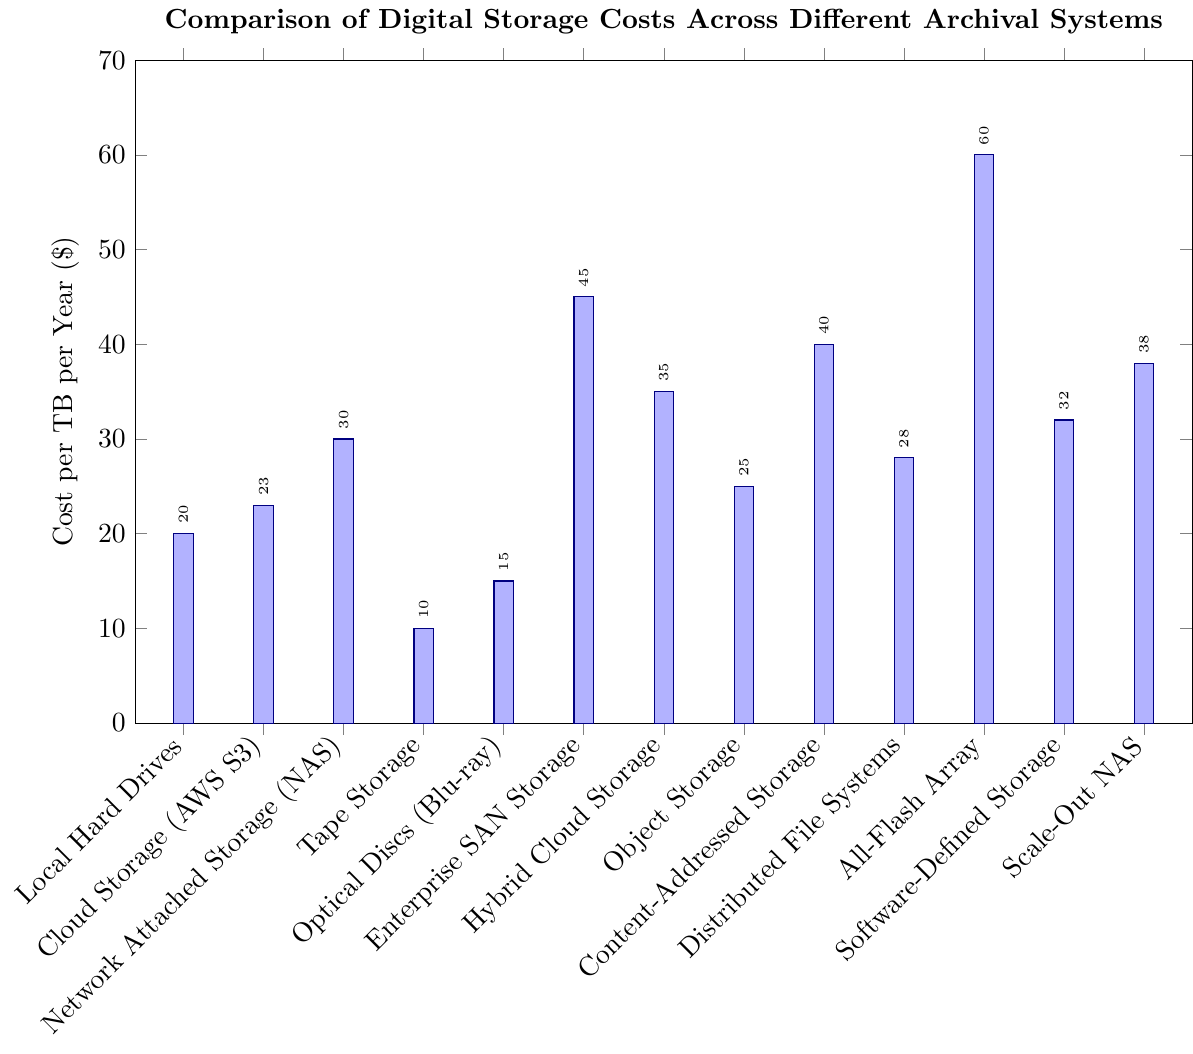Which storage systems have a cost per TB per year less than $20? The bars representing "Tape Storage" and "Optical Discs (Blu-ray)" are both below the $20 mark. Therefore, these are the storage systems with a cost per TB per year less than $20.
Answer: Tape Storage, Optical Discs (Blu-ray) What is the difference in cost per TB per year between the most expensive and the least expensive storage systems? The most expensive storage system is "All-Flash Array" at $60 per TB per year, and the least expensive is "Tape Storage" at $10 per TB per year. The difference between them is $60 - $10 = $50.
Answer: $50 Which storage systems have the same cost per TB per year, and what is that cost? By examining the heights of the bars, none of the storage systems share the exact same cost per TB per year. Therefore, no two storage systems have the same cost.
Answer: None How much more expensive is Enterprise SAN Storage compared to Local Hard Drives? The cost of Enterprise SAN Storage is $45 per TB per year, while the cost of Local Hard Drives is $20 per TB per year. The difference is $45 - $20 = $25.
Answer: $25 What is the total cost per TB per year if you choose Tape Storage and Optical Discs (Blu-ray)? The cost of Tape Storage is $10 per TB per year and Optical Discs (Blu-ray) is $15 per TB per year. The total cost is $10 + $15 = $25.
Answer: $25 Which storage system has the third highest cost per TB per year? The bar heights for costs indicate that the storage systems with the highest, second highest, and third highest costs are "All-Flash Array" ($60), "Enterprise SAN Storage" ($45), and "Content-Addressed Storage" ($40), respectively. The third highest is "Content-Addressed Storage".
Answer: Content-Addressed Storage What is the average cost per TB per year for Cloud Storage (AWS S3), Object Storage, and Distributed File Systems? The costs for Cloud Storage (AWS S3) is $23, Object Storage is $25, and Distributed File Systems is $28. Summing these gives $23 + $25 + $28 = $76. The average is $76 / 3 = $25.33.
Answer: $25.33 Which storage system is depicted with the tallest bar in the chart? The tallest bar in the chart corresponds to the cost of "All-Flash Array," which is $60.
Answer: All-Flash Array Compare the cost per TB per year between hybrid solutions (Hybrid Cloud Storage and Software-Defined Storage) and traditional storage (Tape Storage and Optical Discs (Blu-ray)). Which is generally more expensive? Hybrid Cloud Storage costs $35 and Software-Defined Storage costs $32, combining for a total of $35 + $32 = $67. Tape Storage costs $10 and Optical Discs (Blu-ray) costs $15, combining for $10 + $15 = $25. The combined cost of hybrid solutions is higher than that of traditional storage.
Answer: Hybrid solutions are generally more expensive How many storage systems have a cost per TB per year greater than $30? The storage systems with costs greater than $30 per TB per year are Network Attached Storage (NAS) ($30), Hybrid Cloud Storage ($35), Software-Defined Storage ($32), Scale-Out NAS ($38), Content-Addressed Storage ($40), Enterprise SAN Storage ($45), and All-Flash Array ($60). Counting these, there are 7 such storage systems.
Answer: 7 